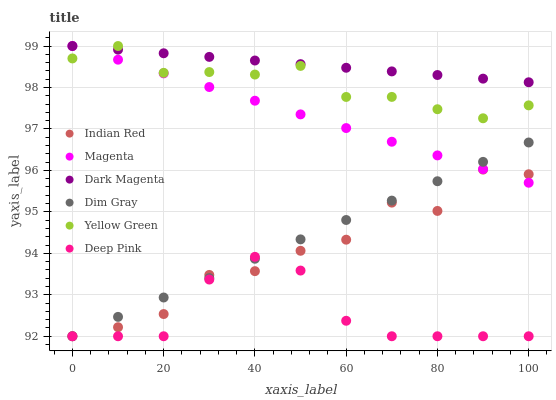Does Deep Pink have the minimum area under the curve?
Answer yes or no. Yes. Does Dark Magenta have the maximum area under the curve?
Answer yes or no. Yes. Does Dim Gray have the minimum area under the curve?
Answer yes or no. No. Does Dim Gray have the maximum area under the curve?
Answer yes or no. No. Is Dim Gray the smoothest?
Answer yes or no. Yes. Is Indian Red the roughest?
Answer yes or no. Yes. Is Dark Magenta the smoothest?
Answer yes or no. No. Is Dark Magenta the roughest?
Answer yes or no. No. Does Deep Pink have the lowest value?
Answer yes or no. Yes. Does Dark Magenta have the lowest value?
Answer yes or no. No. Does Yellow Green have the highest value?
Answer yes or no. Yes. Does Dim Gray have the highest value?
Answer yes or no. No. Is Deep Pink less than Dark Magenta?
Answer yes or no. Yes. Is Dark Magenta greater than Dim Gray?
Answer yes or no. Yes. Does Indian Red intersect Magenta?
Answer yes or no. Yes. Is Indian Red less than Magenta?
Answer yes or no. No. Is Indian Red greater than Magenta?
Answer yes or no. No. Does Deep Pink intersect Dark Magenta?
Answer yes or no. No. 